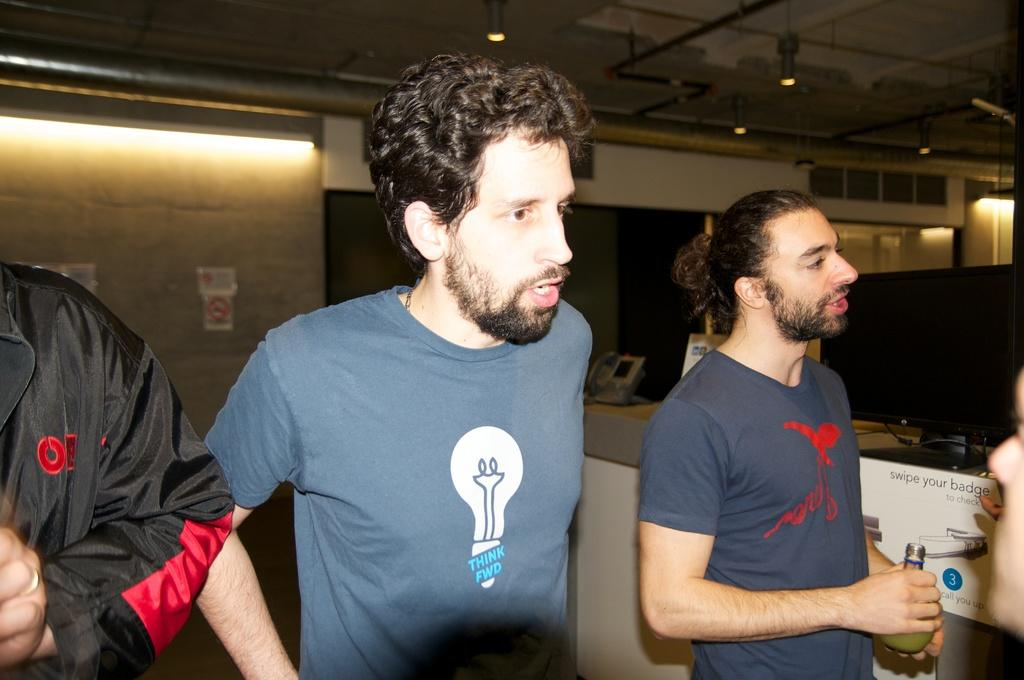How many people are in the image? There are three men in the image. What are the men doing in the image? The men are standing. What can be seen in the background of the image? There is a wall in the background of the image. What type of credit card is the man on the left holding in the image? There is no credit card visible in the image; the men are simply standing. Can you tell me how many cats are present in the image? There are no cats present in the image. 